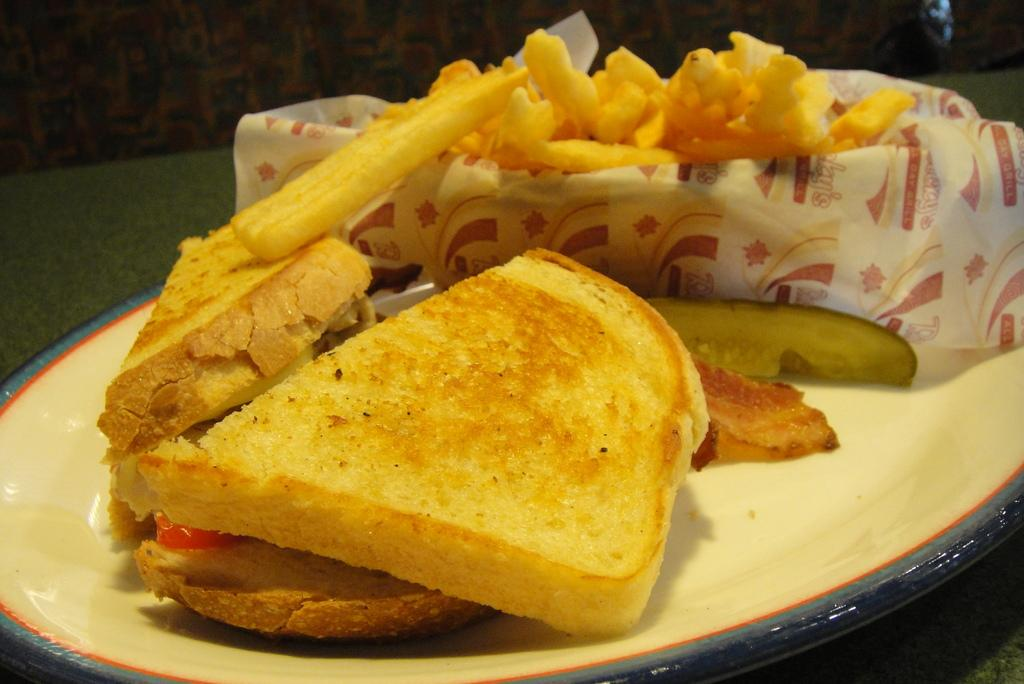What is on the plate that is visible in the image? There is food on a plate in the image. Where is the plate located in the image? The plate is on a table in the image. How many ladybugs can be seen crawling on the food in the image? There are no ladybugs present in the image; it only shows food on a plate. 